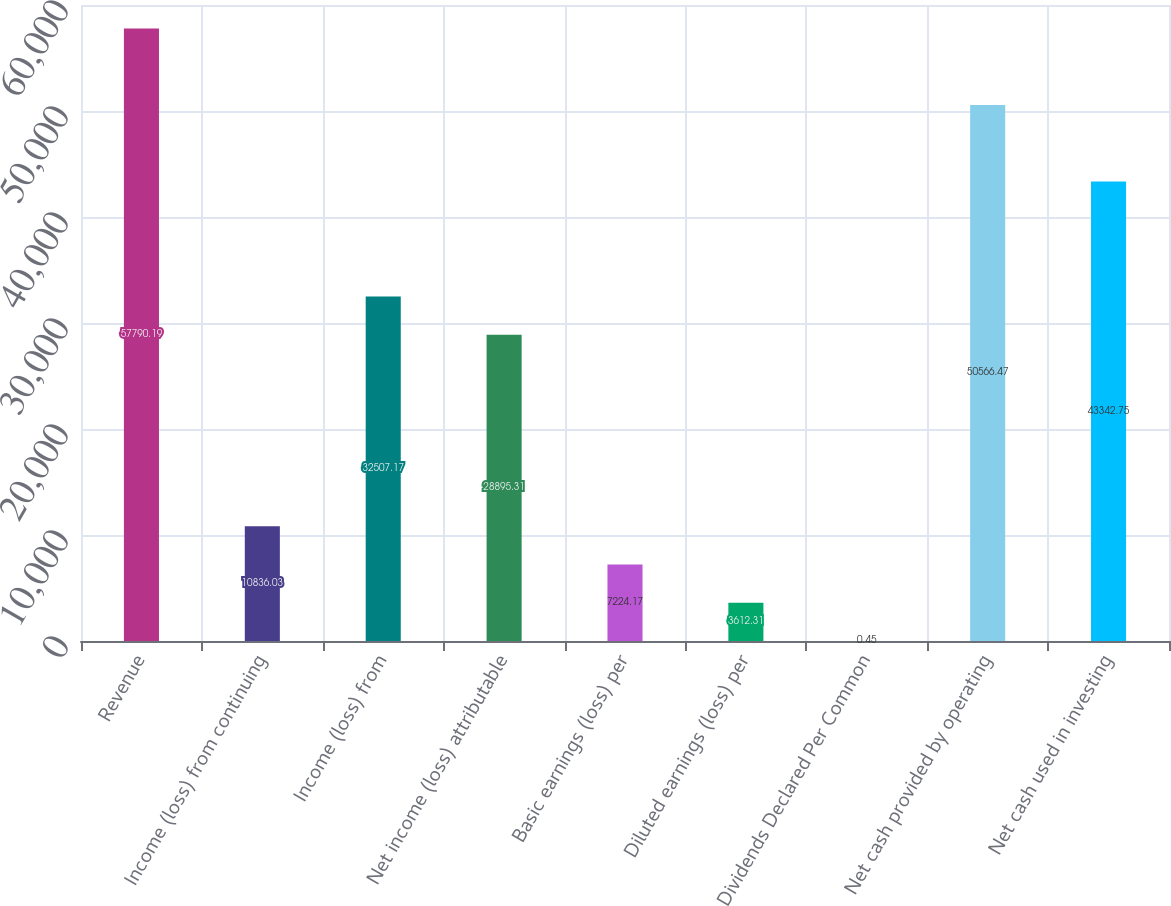Convert chart. <chart><loc_0><loc_0><loc_500><loc_500><bar_chart><fcel>Revenue<fcel>Income (loss) from continuing<fcel>Income (loss) from<fcel>Net income (loss) attributable<fcel>Basic earnings (loss) per<fcel>Diluted earnings (loss) per<fcel>Dividends Declared Per Common<fcel>Net cash provided by operating<fcel>Net cash used in investing<nl><fcel>57790.2<fcel>10836<fcel>32507.2<fcel>28895.3<fcel>7224.17<fcel>3612.31<fcel>0.45<fcel>50566.5<fcel>43342.8<nl></chart> 